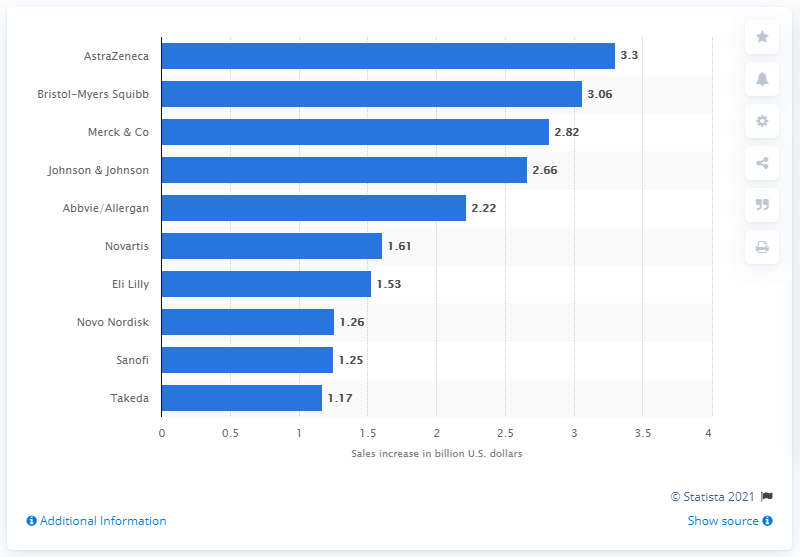Highlight a few significant elements in this photo. It is predicted that AstraZeneca will have the second largest new sales in 2021. 